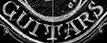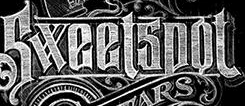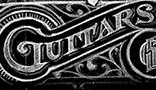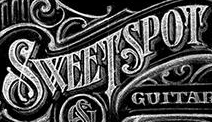Read the text from these images in sequence, separated by a semicolon. GUITARS; Sweetspot; GUITARS; SWEETSPOT 